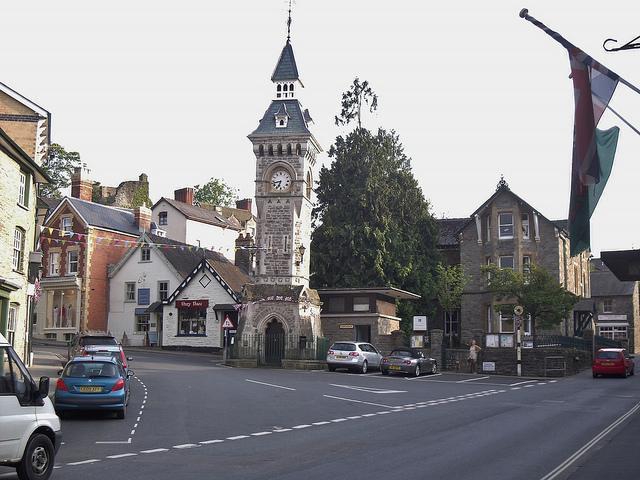How many cars are in the picture?
Give a very brief answer. 7. How many red cars do you see?
Give a very brief answer. 1. How many cars are there?
Give a very brief answer. 2. How many black donut are there this images?
Give a very brief answer. 0. 